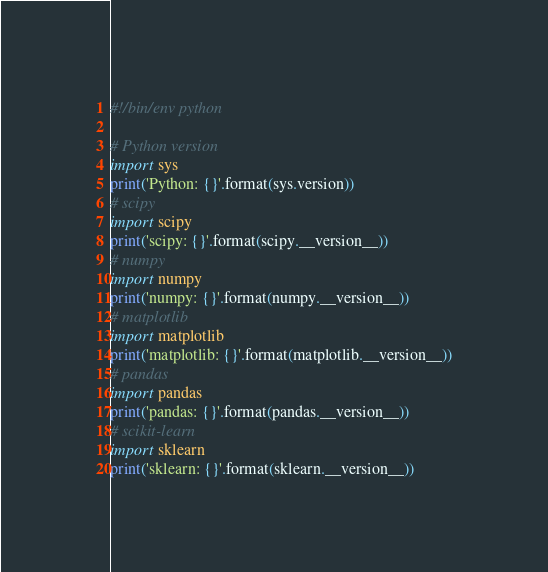<code> <loc_0><loc_0><loc_500><loc_500><_Python_>#!/bin/env python

# Python version
import sys
print('Python: {}'.format(sys.version))
# scipy
import scipy
print('scipy: {}'.format(scipy.__version__))
# numpy
import numpy
print('numpy: {}'.format(numpy.__version__))
# matplotlib
import matplotlib
print('matplotlib: {}'.format(matplotlib.__version__))
# pandas
import pandas
print('pandas: {}'.format(pandas.__version__))
# scikit-learn
import sklearn
print('sklearn: {}'.format(sklearn.__version__))
</code> 